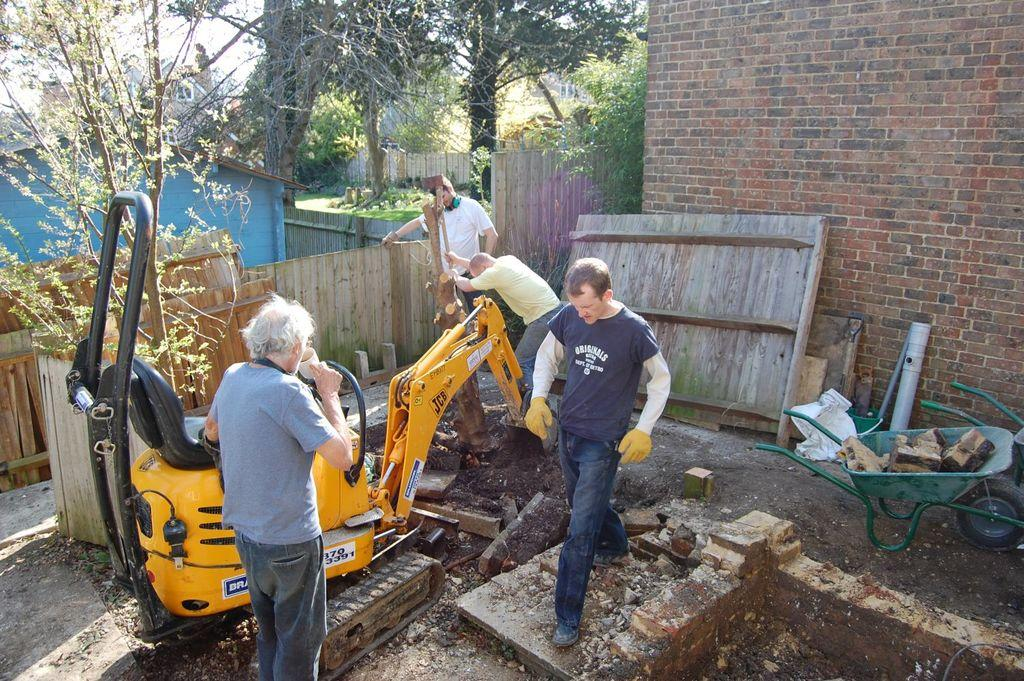How many people are in the image? There is a group of people in the image, but the exact number cannot be determined from the provided facts. What type of vehicle is in the image? There is a vehicle in the image, but the specific type cannot be determined from the provided facts. What are the carts used for in the image? The purpose of the carts in the image cannot be determined from the provided facts. What can be seen in the background of the image? There are houses, a fence, and trees in the background of the image. What type of tank is visible in the image? There is no tank present in the image. Can you describe the trade that is taking place in the image? There is no trade taking place in the image; it features a group of people, a vehicle, carts, and a background with houses, a fence, and trees. 